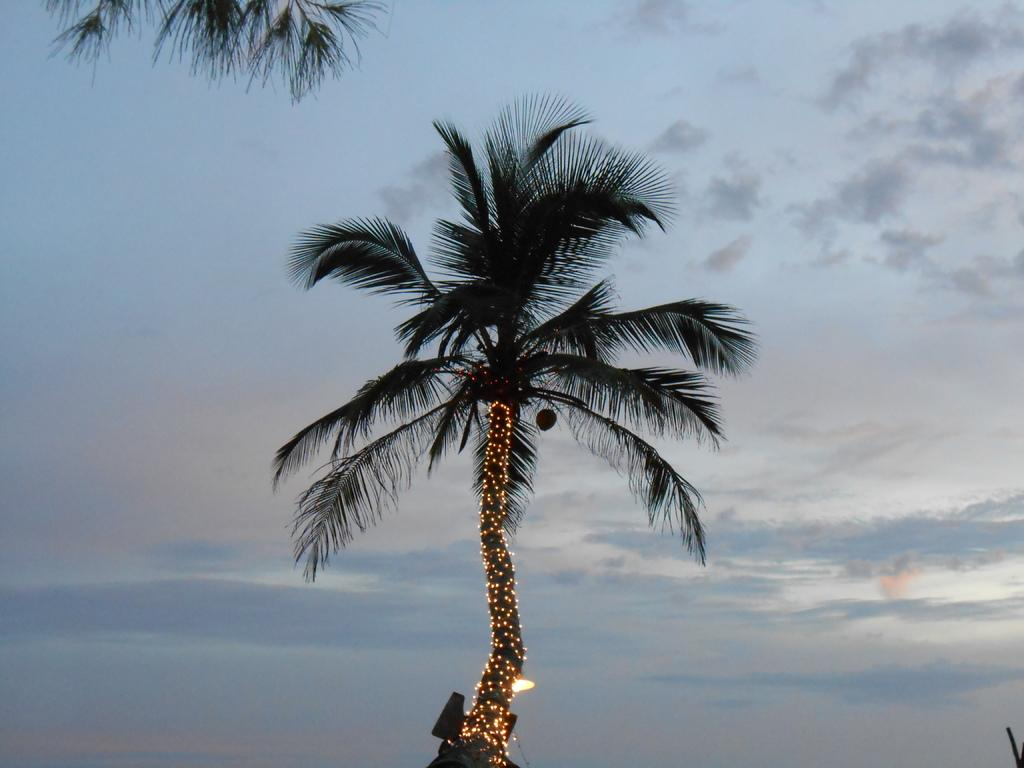What is the main subject in the center of the image? There is a tree in the center of the image. What can be seen in the background of the image? There is sky visible in the background of the image. What type of fear is depicted in the image? There is no fear depicted in the image; it features a tree and sky. What process is being carried out in the image? There is no process being carried out in the image; it simply shows a tree and the sky. 